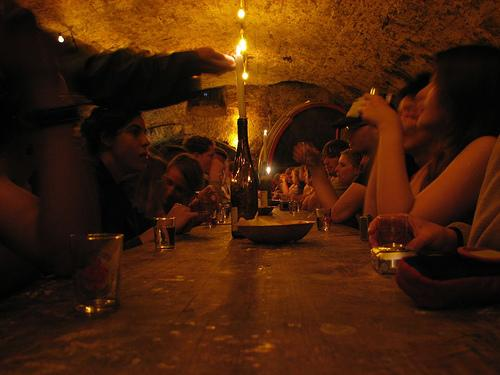What is the name for this style of table? Please explain your reasoning. refectory table. It is a long wooden table shared by many in a pub 